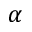Convert formula to latex. <formula><loc_0><loc_0><loc_500><loc_500>\alpha</formula> 